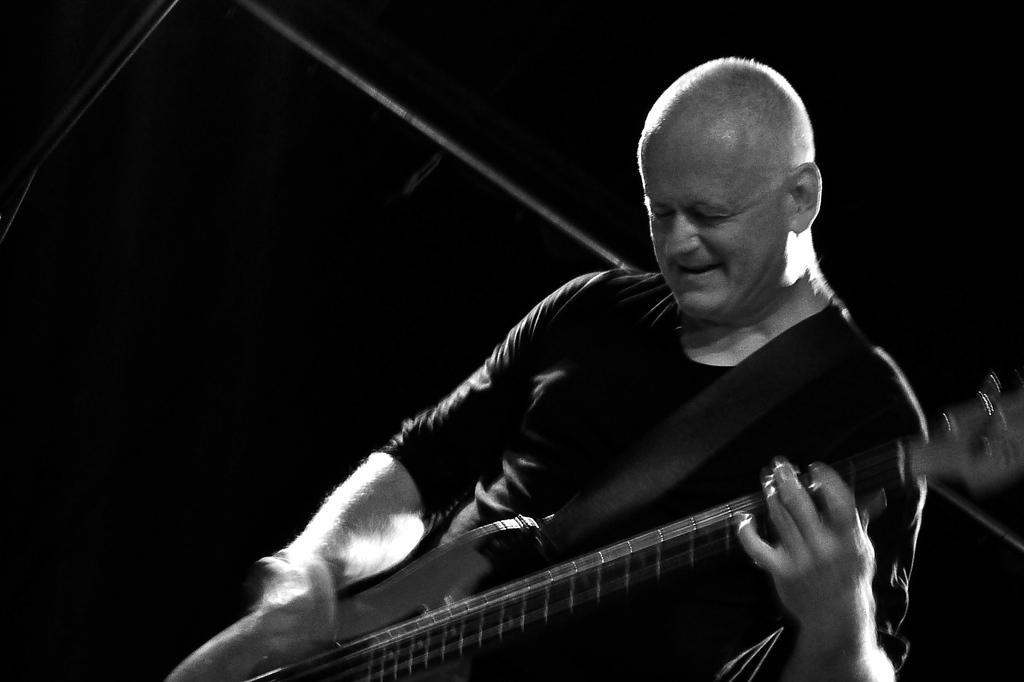In one or two sentences, can you explain what this image depicts? It is a black and white image. In this image we can see the man playing the guitar. In the background we can see some rods and the background is in black color. 